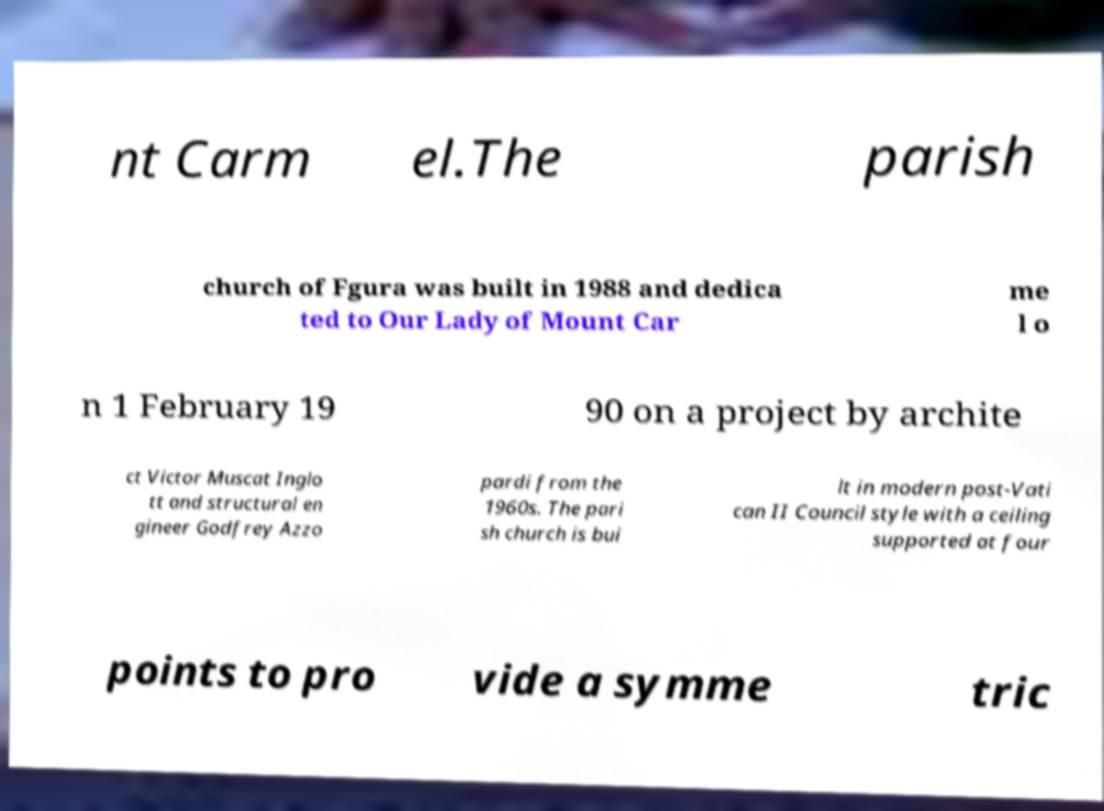Could you assist in decoding the text presented in this image and type it out clearly? nt Carm el.The parish church of Fgura was built in 1988 and dedica ted to Our Lady of Mount Car me l o n 1 February 19 90 on a project by archite ct Victor Muscat Inglo tt and structural en gineer Godfrey Azzo pardi from the 1960s. The pari sh church is bui lt in modern post-Vati can II Council style with a ceiling supported at four points to pro vide a symme tric 